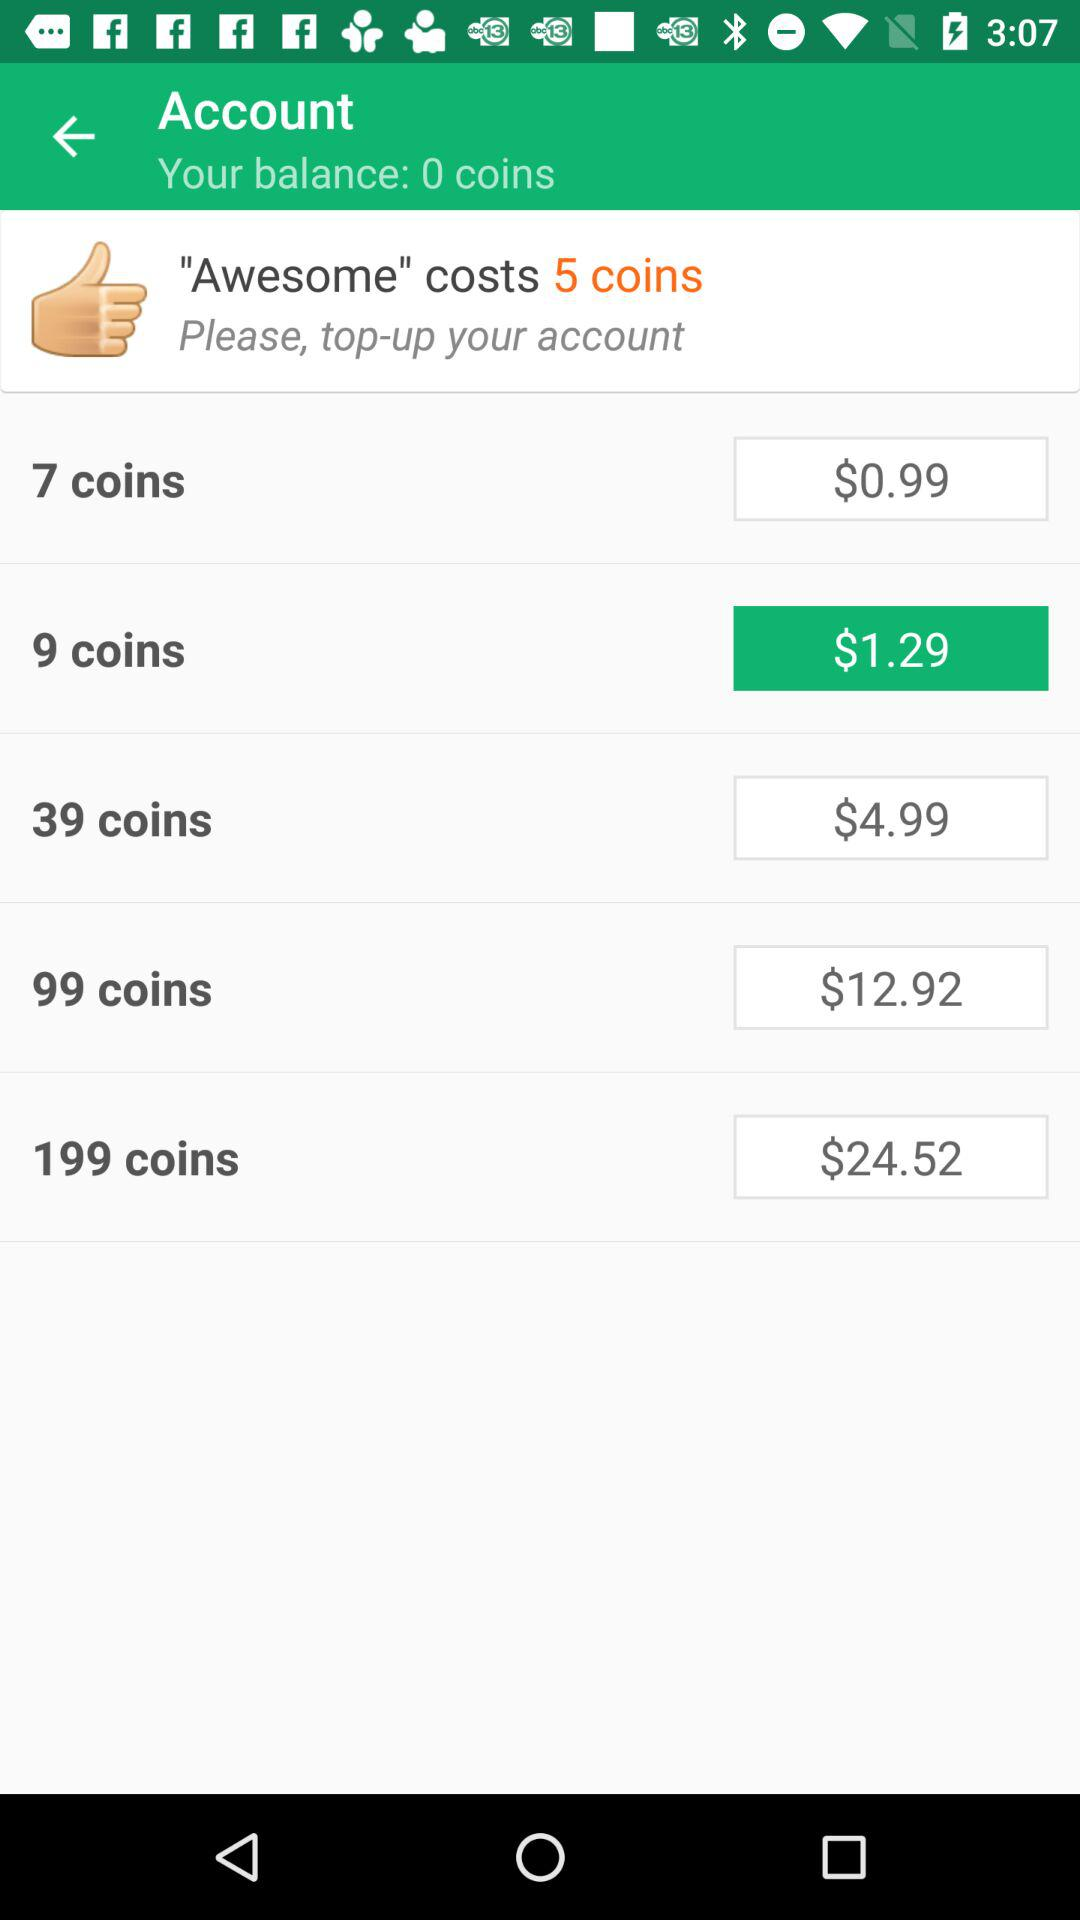What is the currency of prices? The currency is dollars. 